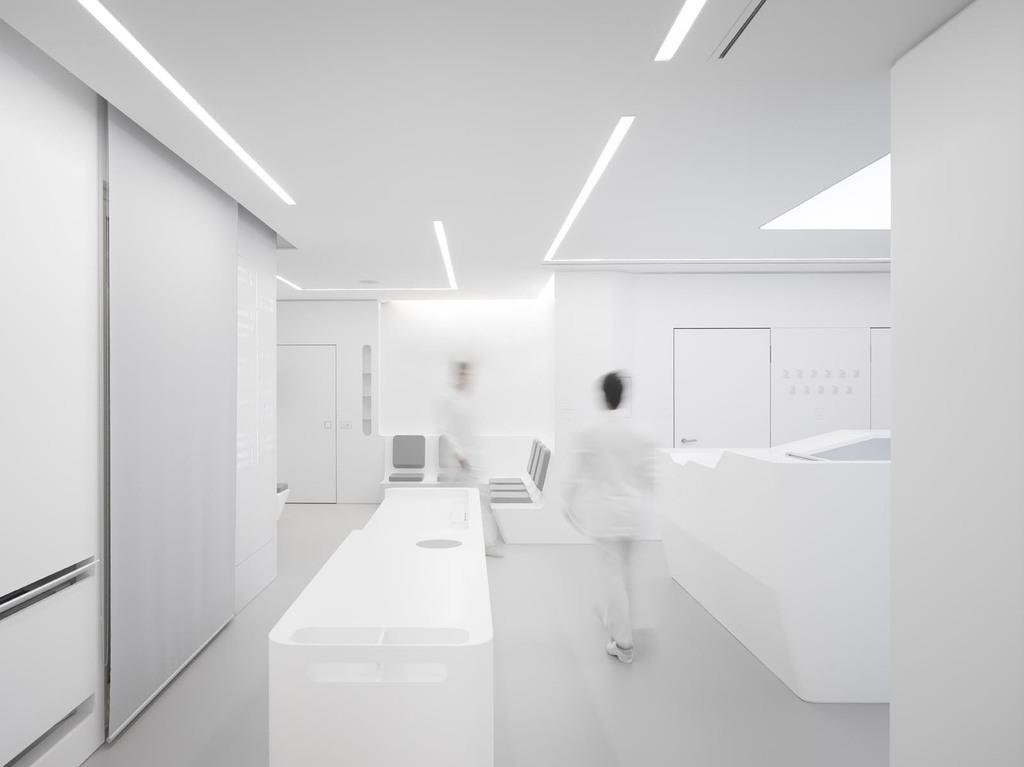How many persons are on the floor in the image? There are two persons on the floor in the image. What type of architectural features can be seen in the image? There are doors, chairs, a table, and a wall visible in the image. What other objects are present in the image? There are other objects in the image, but their specific details are not mentioned in the provided facts. What is visible at the top of the image? There are lights visible at the top of the image. What type of fan is blowing air on the persons on the floor in the image? There is no fan present in the image; it only shows two persons on the floor. 